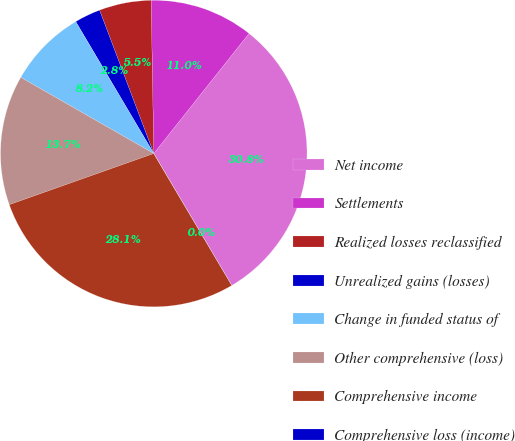Convert chart. <chart><loc_0><loc_0><loc_500><loc_500><pie_chart><fcel>Net income<fcel>Settlements<fcel>Realized losses reclassified<fcel>Unrealized gains (losses)<fcel>Change in funded status of<fcel>Other comprehensive (loss)<fcel>Comprehensive income<fcel>Comprehensive loss (income)<nl><fcel>30.81%<fcel>10.95%<fcel>5.48%<fcel>2.75%<fcel>8.22%<fcel>13.69%<fcel>28.08%<fcel>0.01%<nl></chart> 